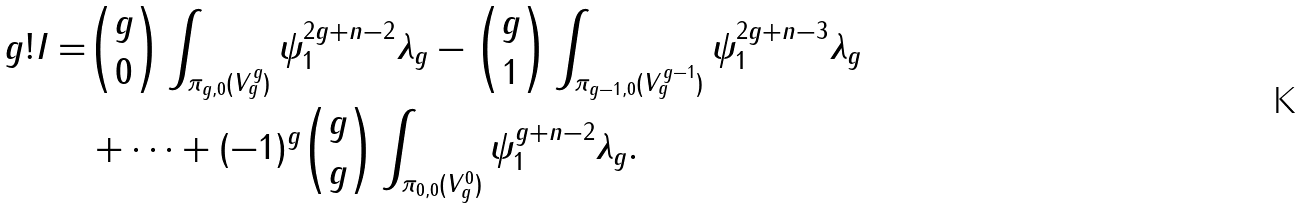Convert formula to latex. <formula><loc_0><loc_0><loc_500><loc_500>g ! I = & \binom { g } { 0 } \int _ { \pi _ { g , 0 } ( V _ { g } ^ { g } ) } \psi _ { 1 } ^ { 2 g + n - 2 } \lambda _ { g } - \binom { g } { 1 } \int _ { \pi _ { g - 1 , 0 } ( V _ { g } ^ { g - 1 } ) } \psi _ { 1 } ^ { 2 g + n - 3 } \lambda _ { g } \\ & + \dots + ( - 1 ) ^ { g } \binom { g } { g } \int _ { \pi _ { 0 , 0 } ( V _ { g } ^ { 0 } ) } \psi _ { 1 } ^ { g + n - 2 } \lambda _ { g } .</formula> 